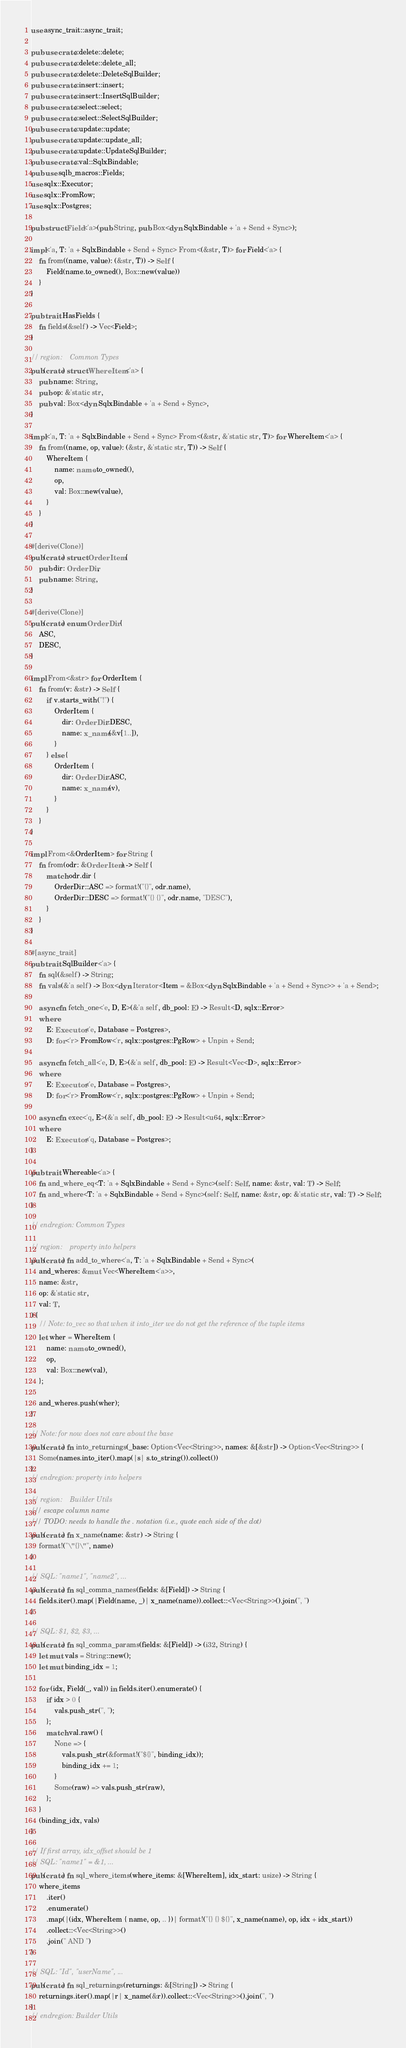Convert code to text. <code><loc_0><loc_0><loc_500><loc_500><_Rust_>use async_trait::async_trait;

pub use crate::delete::delete;
pub use crate::delete::delete_all;
pub use crate::delete::DeleteSqlBuilder;
pub use crate::insert::insert;
pub use crate::insert::InsertSqlBuilder;
pub use crate::select::select;
pub use crate::select::SelectSqlBuilder;
pub use crate::update::update;
pub use crate::update::update_all;
pub use crate::update::UpdateSqlBuilder;
pub use crate::val::SqlxBindable;
pub use sqlb_macros::Fields;
use sqlx::Executor;
use sqlx::FromRow;
use sqlx::Postgres;

pub struct Field<'a>(pub String, pub Box<dyn SqlxBindable + 'a + Send + Sync>);

impl<'a, T: 'a + SqlxBindable + Send + Sync> From<(&str, T)> for Field<'a> {
	fn from((name, value): (&str, T)) -> Self {
		Field(name.to_owned(), Box::new(value))
	}
}

pub trait HasFields {
	fn fields(&self) -> Vec<Field>;
}

// region:    Common Types
pub(crate) struct WhereItem<'a> {
	pub name: String,
	pub op: &'static str,
	pub val: Box<dyn SqlxBindable + 'a + Send + Sync>,
}

impl<'a, T: 'a + SqlxBindable + Send + Sync> From<(&str, &'static str, T)> for WhereItem<'a> {
	fn from((name, op, value): (&str, &'static str, T)) -> Self {
		WhereItem {
			name: name.to_owned(),
			op,
			val: Box::new(value),
		}
	}
}

#[derive(Clone)]
pub(crate) struct OrderItem {
	pub dir: OrderDir,
	pub name: String,
}

#[derive(Clone)]
pub(crate) enum OrderDir {
	ASC,
	DESC,
}

impl From<&str> for OrderItem {
	fn from(v: &str) -> Self {
		if v.starts_with("!") {
			OrderItem {
				dir: OrderDir::DESC,
				name: x_name(&v[1..]),
			}
		} else {
			OrderItem {
				dir: OrderDir::ASC,
				name: x_name(v),
			}
		}
	}
}

impl From<&OrderItem> for String {
	fn from(odr: &OrderItem) -> Self {
		match odr.dir {
			OrderDir::ASC => format!("{}", odr.name),
			OrderDir::DESC => format!("{} {}", odr.name, "DESC"),
		}
	}
}

#[async_trait]
pub trait SqlBuilder<'a> {
	fn sql(&self) -> String;
	fn vals(&'a self) -> Box<dyn Iterator<Item = &Box<dyn SqlxBindable + 'a + Send + Sync>> + 'a + Send>;

	async fn fetch_one<'e, D, E>(&'a self, db_pool: E) -> Result<D, sqlx::Error>
	where
		E: Executor<'e, Database = Postgres>,
		D: for<'r> FromRow<'r, sqlx::postgres::PgRow> + Unpin + Send;

	async fn fetch_all<'e, D, E>(&'a self, db_pool: E) -> Result<Vec<D>, sqlx::Error>
	where
		E: Executor<'e, Database = Postgres>,
		D: for<'r> FromRow<'r, sqlx::postgres::PgRow> + Unpin + Send;

	async fn exec<'q, E>(&'a self, db_pool: E) -> Result<u64, sqlx::Error>
	where
		E: Executor<'q, Database = Postgres>;
}

pub trait Whereable<'a> {
	fn and_where_eq<T: 'a + SqlxBindable + Send + Sync>(self: Self, name: &str, val: T) -> Self;
	fn and_where<T: 'a + SqlxBindable + Send + Sync>(self: Self, name: &str, op: &'static str, val: T) -> Self;
}

// endregion: Common Types

// region:    property into helpers
pub(crate) fn add_to_where<'a, T: 'a + SqlxBindable + Send + Sync>(
	and_wheres: &mut Vec<WhereItem<'a>>,
	name: &str,
	op: &'static str,
	val: T,
) {
	// Note: to_vec so that when it into_iter we do not get the reference of the tuple items
	let wher = WhereItem {
		name: name.to_owned(),
		op,
		val: Box::new(val),
	};

	and_wheres.push(wher);
}

// Note: for now does not care about the base
pub(crate) fn into_returnings(_base: Option<Vec<String>>, names: &[&str]) -> Option<Vec<String>> {
	Some(names.into_iter().map(|s| s.to_string()).collect())
}
// endregion: property into helpers

// region:    Builder Utils
/// escape column name
/// TODO: needs to handle the . notation (i.e., quote each side of the dot)
pub(crate) fn x_name(name: &str) -> String {
	format!("\"{}\"", name)
}

// SQL: "name1", "name2", ...
pub(crate) fn sql_comma_names(fields: &[Field]) -> String {
	fields.iter().map(|Field(name, _)| x_name(name)).collect::<Vec<String>>().join(", ")
}

// SQL: $1, $2, $3, ...
pub(crate) fn sql_comma_params(fields: &[Field]) -> (i32, String) {
	let mut vals = String::new();
	let mut binding_idx = 1;

	for (idx, Field(_, val)) in fields.iter().enumerate() {
		if idx > 0 {
			vals.push_str(", ");
		};
		match val.raw() {
			None => {
				vals.push_str(&format!("${}", binding_idx));
				binding_idx += 1;
			}
			Some(raw) => vals.push_str(raw),
		};
	}
	(binding_idx, vals)
}

// If first array, idx_offset should be 1
// SQL: "name1" = &1, ...
pub(crate) fn sql_where_items(where_items: &[WhereItem], idx_start: usize) -> String {
	where_items
		.iter()
		.enumerate()
		.map(|(idx, WhereItem { name, op, .. })| format!("{} {} ${}", x_name(name), op, idx + idx_start))
		.collect::<Vec<String>>()
		.join(" AND ")
}

// SQL: "Id", "userName", ...
pub(crate) fn sql_returnings(returnings: &[String]) -> String {
	returnings.iter().map(|r| x_name(&r)).collect::<Vec<String>>().join(", ")
}
// endregion: Builder Utils
</code> 